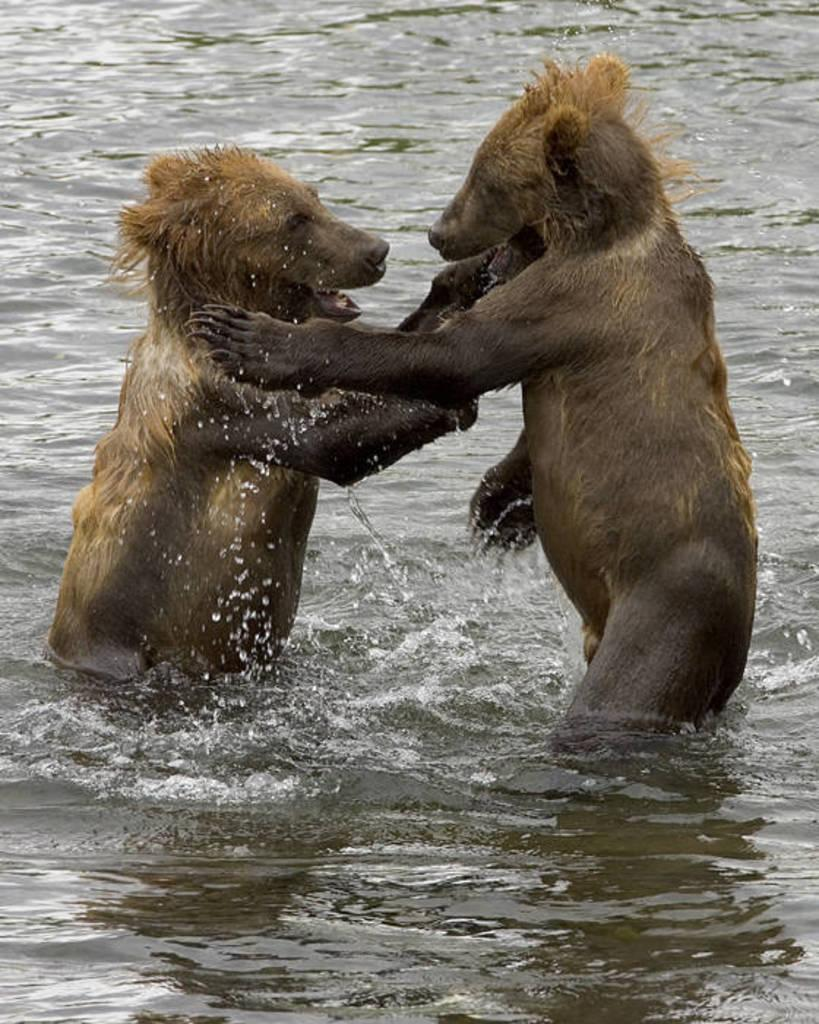What animals are in the foreground of the image? There are two bears in the foreground of the image. Where are the bears located? The bears are in the water. What type of plantation can be seen in the background of the image? There is no plantation present in the image; it features two bears in the water. How many fangs can be seen on the bears in the image? The image does not show the bears' teeth, so it is not possible to determine the number of fangs. 